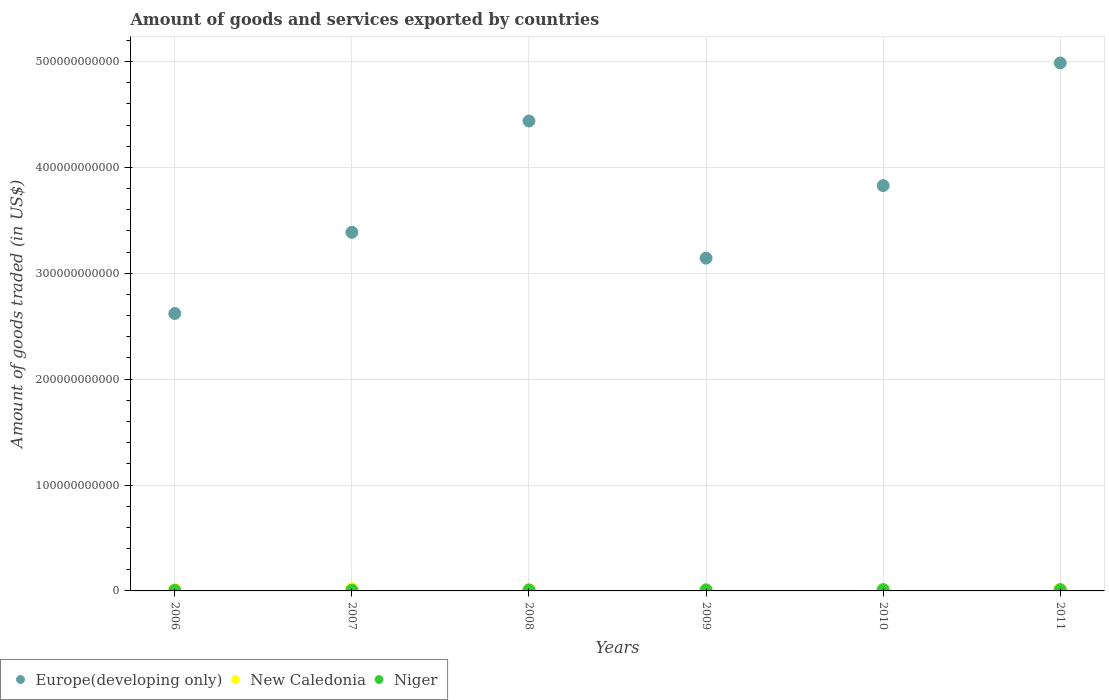How many different coloured dotlines are there?
Offer a very short reply. 3. What is the total amount of goods and services exported in Europe(developing only) in 2010?
Offer a very short reply. 3.83e+11. Across all years, what is the maximum total amount of goods and services exported in Niger?
Your response must be concise. 1.17e+09. Across all years, what is the minimum total amount of goods and services exported in New Caledonia?
Your answer should be very brief. 9.72e+08. What is the total total amount of goods and services exported in New Caledonia in the graph?
Ensure brevity in your answer.  8.77e+09. What is the difference between the total amount of goods and services exported in New Caledonia in 2006 and that in 2009?
Give a very brief answer. 3.71e+08. What is the difference between the total amount of goods and services exported in New Caledonia in 2006 and the total amount of goods and services exported in Niger in 2010?
Offer a terse response. 1.93e+08. What is the average total amount of goods and services exported in Europe(developing only) per year?
Offer a very short reply. 3.73e+11. In the year 2006, what is the difference between the total amount of goods and services exported in Europe(developing only) and total amount of goods and services exported in New Caledonia?
Your answer should be very brief. 2.61e+11. In how many years, is the total amount of goods and services exported in Europe(developing only) greater than 340000000000 US$?
Provide a succinct answer. 3. What is the ratio of the total amount of goods and services exported in New Caledonia in 2009 to that in 2010?
Make the answer very short. 0.69. Is the total amount of goods and services exported in Niger in 2008 less than that in 2010?
Your answer should be compact. Yes. Is the difference between the total amount of goods and services exported in Europe(developing only) in 2009 and 2011 greater than the difference between the total amount of goods and services exported in New Caledonia in 2009 and 2011?
Your answer should be very brief. No. What is the difference between the highest and the second highest total amount of goods and services exported in New Caledonia?
Offer a terse response. 4.38e+08. What is the difference between the highest and the lowest total amount of goods and services exported in Europe(developing only)?
Offer a very short reply. 2.37e+11. In how many years, is the total amount of goods and services exported in Europe(developing only) greater than the average total amount of goods and services exported in Europe(developing only) taken over all years?
Provide a short and direct response. 3. Is the total amount of goods and services exported in Niger strictly greater than the total amount of goods and services exported in New Caledonia over the years?
Provide a short and direct response. No. How many years are there in the graph?
Keep it short and to the point. 6. What is the difference between two consecutive major ticks on the Y-axis?
Offer a terse response. 1.00e+11. Does the graph contain grids?
Keep it short and to the point. Yes. What is the title of the graph?
Ensure brevity in your answer.  Amount of goods and services exported by countries. What is the label or title of the X-axis?
Your answer should be very brief. Years. What is the label or title of the Y-axis?
Make the answer very short. Amount of goods traded (in US$). What is the Amount of goods traded (in US$) of Europe(developing only) in 2006?
Your response must be concise. 2.62e+11. What is the Amount of goods traded (in US$) in New Caledonia in 2006?
Offer a terse response. 1.34e+09. What is the Amount of goods traded (in US$) of Niger in 2006?
Your answer should be compact. 5.08e+08. What is the Amount of goods traded (in US$) in Europe(developing only) in 2007?
Offer a very short reply. 3.39e+11. What is the Amount of goods traded (in US$) of New Caledonia in 2007?
Your answer should be compact. 2.12e+09. What is the Amount of goods traded (in US$) of Niger in 2007?
Ensure brevity in your answer.  6.63e+08. What is the Amount of goods traded (in US$) of Europe(developing only) in 2008?
Your response must be concise. 4.44e+11. What is the Amount of goods traded (in US$) in New Caledonia in 2008?
Make the answer very short. 1.23e+09. What is the Amount of goods traded (in US$) in Niger in 2008?
Make the answer very short. 9.12e+08. What is the Amount of goods traded (in US$) in Europe(developing only) in 2009?
Offer a terse response. 3.14e+11. What is the Amount of goods traded (in US$) of New Caledonia in 2009?
Keep it short and to the point. 9.72e+08. What is the Amount of goods traded (in US$) of Niger in 2009?
Give a very brief answer. 9.97e+08. What is the Amount of goods traded (in US$) of Europe(developing only) in 2010?
Keep it short and to the point. 3.83e+11. What is the Amount of goods traded (in US$) in New Caledonia in 2010?
Your answer should be compact. 1.42e+09. What is the Amount of goods traded (in US$) of Niger in 2010?
Your answer should be compact. 1.15e+09. What is the Amount of goods traded (in US$) of Europe(developing only) in 2011?
Provide a short and direct response. 4.99e+11. What is the Amount of goods traded (in US$) in New Caledonia in 2011?
Give a very brief answer. 1.68e+09. What is the Amount of goods traded (in US$) of Niger in 2011?
Ensure brevity in your answer.  1.17e+09. Across all years, what is the maximum Amount of goods traded (in US$) of Europe(developing only)?
Your answer should be very brief. 4.99e+11. Across all years, what is the maximum Amount of goods traded (in US$) of New Caledonia?
Provide a short and direct response. 2.12e+09. Across all years, what is the maximum Amount of goods traded (in US$) of Niger?
Your response must be concise. 1.17e+09. Across all years, what is the minimum Amount of goods traded (in US$) of Europe(developing only)?
Offer a terse response. 2.62e+11. Across all years, what is the minimum Amount of goods traded (in US$) of New Caledonia?
Keep it short and to the point. 9.72e+08. Across all years, what is the minimum Amount of goods traded (in US$) in Niger?
Provide a succinct answer. 5.08e+08. What is the total Amount of goods traded (in US$) of Europe(developing only) in the graph?
Keep it short and to the point. 2.24e+12. What is the total Amount of goods traded (in US$) of New Caledonia in the graph?
Your response must be concise. 8.77e+09. What is the total Amount of goods traded (in US$) of Niger in the graph?
Keep it short and to the point. 5.40e+09. What is the difference between the Amount of goods traded (in US$) in Europe(developing only) in 2006 and that in 2007?
Keep it short and to the point. -7.67e+1. What is the difference between the Amount of goods traded (in US$) in New Caledonia in 2006 and that in 2007?
Give a very brief answer. -7.79e+08. What is the difference between the Amount of goods traded (in US$) of Niger in 2006 and that in 2007?
Your answer should be compact. -1.55e+08. What is the difference between the Amount of goods traded (in US$) in Europe(developing only) in 2006 and that in 2008?
Ensure brevity in your answer.  -1.82e+11. What is the difference between the Amount of goods traded (in US$) of New Caledonia in 2006 and that in 2008?
Offer a terse response. 1.11e+08. What is the difference between the Amount of goods traded (in US$) in Niger in 2006 and that in 2008?
Offer a terse response. -4.04e+08. What is the difference between the Amount of goods traded (in US$) of Europe(developing only) in 2006 and that in 2009?
Your answer should be very brief. -5.23e+1. What is the difference between the Amount of goods traded (in US$) in New Caledonia in 2006 and that in 2009?
Provide a succinct answer. 3.71e+08. What is the difference between the Amount of goods traded (in US$) in Niger in 2006 and that in 2009?
Give a very brief answer. -4.89e+08. What is the difference between the Amount of goods traded (in US$) in Europe(developing only) in 2006 and that in 2010?
Keep it short and to the point. -1.21e+11. What is the difference between the Amount of goods traded (in US$) of New Caledonia in 2006 and that in 2010?
Provide a succinct answer. -7.29e+07. What is the difference between the Amount of goods traded (in US$) of Niger in 2006 and that in 2010?
Offer a terse response. -6.43e+08. What is the difference between the Amount of goods traded (in US$) of Europe(developing only) in 2006 and that in 2011?
Your response must be concise. -2.37e+11. What is the difference between the Amount of goods traded (in US$) in New Caledonia in 2006 and that in 2011?
Your answer should be compact. -3.40e+08. What is the difference between the Amount of goods traded (in US$) in Niger in 2006 and that in 2011?
Offer a very short reply. -6.65e+08. What is the difference between the Amount of goods traded (in US$) of Europe(developing only) in 2007 and that in 2008?
Make the answer very short. -1.05e+11. What is the difference between the Amount of goods traded (in US$) in New Caledonia in 2007 and that in 2008?
Your answer should be very brief. 8.90e+08. What is the difference between the Amount of goods traded (in US$) in Niger in 2007 and that in 2008?
Your answer should be compact. -2.50e+08. What is the difference between the Amount of goods traded (in US$) of Europe(developing only) in 2007 and that in 2009?
Offer a very short reply. 2.44e+1. What is the difference between the Amount of goods traded (in US$) in New Caledonia in 2007 and that in 2009?
Offer a terse response. 1.15e+09. What is the difference between the Amount of goods traded (in US$) in Niger in 2007 and that in 2009?
Your answer should be very brief. -3.34e+08. What is the difference between the Amount of goods traded (in US$) in Europe(developing only) in 2007 and that in 2010?
Provide a succinct answer. -4.41e+1. What is the difference between the Amount of goods traded (in US$) in New Caledonia in 2007 and that in 2010?
Provide a succinct answer. 7.06e+08. What is the difference between the Amount of goods traded (in US$) of Niger in 2007 and that in 2010?
Provide a succinct answer. -4.88e+08. What is the difference between the Amount of goods traded (in US$) of Europe(developing only) in 2007 and that in 2011?
Make the answer very short. -1.60e+11. What is the difference between the Amount of goods traded (in US$) of New Caledonia in 2007 and that in 2011?
Offer a very short reply. 4.38e+08. What is the difference between the Amount of goods traded (in US$) in Niger in 2007 and that in 2011?
Give a very brief answer. -5.10e+08. What is the difference between the Amount of goods traded (in US$) in Europe(developing only) in 2008 and that in 2009?
Provide a succinct answer. 1.29e+11. What is the difference between the Amount of goods traded (in US$) of New Caledonia in 2008 and that in 2009?
Keep it short and to the point. 2.60e+08. What is the difference between the Amount of goods traded (in US$) of Niger in 2008 and that in 2009?
Your answer should be very brief. -8.47e+07. What is the difference between the Amount of goods traded (in US$) in Europe(developing only) in 2008 and that in 2010?
Your answer should be compact. 6.10e+1. What is the difference between the Amount of goods traded (in US$) in New Caledonia in 2008 and that in 2010?
Offer a very short reply. -1.84e+08. What is the difference between the Amount of goods traded (in US$) in Niger in 2008 and that in 2010?
Keep it short and to the point. -2.39e+08. What is the difference between the Amount of goods traded (in US$) of Europe(developing only) in 2008 and that in 2011?
Offer a very short reply. -5.48e+1. What is the difference between the Amount of goods traded (in US$) of New Caledonia in 2008 and that in 2011?
Provide a succinct answer. -4.51e+08. What is the difference between the Amount of goods traded (in US$) of Niger in 2008 and that in 2011?
Offer a terse response. -2.61e+08. What is the difference between the Amount of goods traded (in US$) in Europe(developing only) in 2009 and that in 2010?
Your response must be concise. -6.85e+1. What is the difference between the Amount of goods traded (in US$) of New Caledonia in 2009 and that in 2010?
Offer a very short reply. -4.44e+08. What is the difference between the Amount of goods traded (in US$) in Niger in 2009 and that in 2010?
Offer a terse response. -1.54e+08. What is the difference between the Amount of goods traded (in US$) of Europe(developing only) in 2009 and that in 2011?
Ensure brevity in your answer.  -1.84e+11. What is the difference between the Amount of goods traded (in US$) in New Caledonia in 2009 and that in 2011?
Your response must be concise. -7.12e+08. What is the difference between the Amount of goods traded (in US$) in Niger in 2009 and that in 2011?
Offer a very short reply. -1.76e+08. What is the difference between the Amount of goods traded (in US$) of Europe(developing only) in 2010 and that in 2011?
Offer a very short reply. -1.16e+11. What is the difference between the Amount of goods traded (in US$) in New Caledonia in 2010 and that in 2011?
Your response must be concise. -2.67e+08. What is the difference between the Amount of goods traded (in US$) of Niger in 2010 and that in 2011?
Offer a terse response. -2.17e+07. What is the difference between the Amount of goods traded (in US$) of Europe(developing only) in 2006 and the Amount of goods traded (in US$) of New Caledonia in 2007?
Offer a very short reply. 2.60e+11. What is the difference between the Amount of goods traded (in US$) in Europe(developing only) in 2006 and the Amount of goods traded (in US$) in Niger in 2007?
Ensure brevity in your answer.  2.61e+11. What is the difference between the Amount of goods traded (in US$) in New Caledonia in 2006 and the Amount of goods traded (in US$) in Niger in 2007?
Your response must be concise. 6.81e+08. What is the difference between the Amount of goods traded (in US$) of Europe(developing only) in 2006 and the Amount of goods traded (in US$) of New Caledonia in 2008?
Make the answer very short. 2.61e+11. What is the difference between the Amount of goods traded (in US$) in Europe(developing only) in 2006 and the Amount of goods traded (in US$) in Niger in 2008?
Offer a very short reply. 2.61e+11. What is the difference between the Amount of goods traded (in US$) of New Caledonia in 2006 and the Amount of goods traded (in US$) of Niger in 2008?
Provide a succinct answer. 4.31e+08. What is the difference between the Amount of goods traded (in US$) of Europe(developing only) in 2006 and the Amount of goods traded (in US$) of New Caledonia in 2009?
Offer a very short reply. 2.61e+11. What is the difference between the Amount of goods traded (in US$) in Europe(developing only) in 2006 and the Amount of goods traded (in US$) in Niger in 2009?
Ensure brevity in your answer.  2.61e+11. What is the difference between the Amount of goods traded (in US$) in New Caledonia in 2006 and the Amount of goods traded (in US$) in Niger in 2009?
Provide a succinct answer. 3.47e+08. What is the difference between the Amount of goods traded (in US$) of Europe(developing only) in 2006 and the Amount of goods traded (in US$) of New Caledonia in 2010?
Make the answer very short. 2.61e+11. What is the difference between the Amount of goods traded (in US$) of Europe(developing only) in 2006 and the Amount of goods traded (in US$) of Niger in 2010?
Offer a very short reply. 2.61e+11. What is the difference between the Amount of goods traded (in US$) of New Caledonia in 2006 and the Amount of goods traded (in US$) of Niger in 2010?
Your answer should be very brief. 1.93e+08. What is the difference between the Amount of goods traded (in US$) of Europe(developing only) in 2006 and the Amount of goods traded (in US$) of New Caledonia in 2011?
Keep it short and to the point. 2.60e+11. What is the difference between the Amount of goods traded (in US$) in Europe(developing only) in 2006 and the Amount of goods traded (in US$) in Niger in 2011?
Give a very brief answer. 2.61e+11. What is the difference between the Amount of goods traded (in US$) in New Caledonia in 2006 and the Amount of goods traded (in US$) in Niger in 2011?
Provide a short and direct response. 1.71e+08. What is the difference between the Amount of goods traded (in US$) in Europe(developing only) in 2007 and the Amount of goods traded (in US$) in New Caledonia in 2008?
Provide a short and direct response. 3.37e+11. What is the difference between the Amount of goods traded (in US$) of Europe(developing only) in 2007 and the Amount of goods traded (in US$) of Niger in 2008?
Offer a very short reply. 3.38e+11. What is the difference between the Amount of goods traded (in US$) of New Caledonia in 2007 and the Amount of goods traded (in US$) of Niger in 2008?
Make the answer very short. 1.21e+09. What is the difference between the Amount of goods traded (in US$) of Europe(developing only) in 2007 and the Amount of goods traded (in US$) of New Caledonia in 2009?
Give a very brief answer. 3.38e+11. What is the difference between the Amount of goods traded (in US$) in Europe(developing only) in 2007 and the Amount of goods traded (in US$) in Niger in 2009?
Your answer should be compact. 3.38e+11. What is the difference between the Amount of goods traded (in US$) of New Caledonia in 2007 and the Amount of goods traded (in US$) of Niger in 2009?
Provide a short and direct response. 1.13e+09. What is the difference between the Amount of goods traded (in US$) in Europe(developing only) in 2007 and the Amount of goods traded (in US$) in New Caledonia in 2010?
Make the answer very short. 3.37e+11. What is the difference between the Amount of goods traded (in US$) in Europe(developing only) in 2007 and the Amount of goods traded (in US$) in Niger in 2010?
Make the answer very short. 3.38e+11. What is the difference between the Amount of goods traded (in US$) of New Caledonia in 2007 and the Amount of goods traded (in US$) of Niger in 2010?
Provide a succinct answer. 9.71e+08. What is the difference between the Amount of goods traded (in US$) in Europe(developing only) in 2007 and the Amount of goods traded (in US$) in New Caledonia in 2011?
Provide a succinct answer. 3.37e+11. What is the difference between the Amount of goods traded (in US$) in Europe(developing only) in 2007 and the Amount of goods traded (in US$) in Niger in 2011?
Provide a succinct answer. 3.38e+11. What is the difference between the Amount of goods traded (in US$) in New Caledonia in 2007 and the Amount of goods traded (in US$) in Niger in 2011?
Provide a short and direct response. 9.50e+08. What is the difference between the Amount of goods traded (in US$) in Europe(developing only) in 2008 and the Amount of goods traded (in US$) in New Caledonia in 2009?
Make the answer very short. 4.43e+11. What is the difference between the Amount of goods traded (in US$) in Europe(developing only) in 2008 and the Amount of goods traded (in US$) in Niger in 2009?
Ensure brevity in your answer.  4.43e+11. What is the difference between the Amount of goods traded (in US$) in New Caledonia in 2008 and the Amount of goods traded (in US$) in Niger in 2009?
Ensure brevity in your answer.  2.36e+08. What is the difference between the Amount of goods traded (in US$) in Europe(developing only) in 2008 and the Amount of goods traded (in US$) in New Caledonia in 2010?
Your response must be concise. 4.42e+11. What is the difference between the Amount of goods traded (in US$) of Europe(developing only) in 2008 and the Amount of goods traded (in US$) of Niger in 2010?
Your answer should be very brief. 4.43e+11. What is the difference between the Amount of goods traded (in US$) in New Caledonia in 2008 and the Amount of goods traded (in US$) in Niger in 2010?
Provide a short and direct response. 8.17e+07. What is the difference between the Amount of goods traded (in US$) in Europe(developing only) in 2008 and the Amount of goods traded (in US$) in New Caledonia in 2011?
Your response must be concise. 4.42e+11. What is the difference between the Amount of goods traded (in US$) of Europe(developing only) in 2008 and the Amount of goods traded (in US$) of Niger in 2011?
Your answer should be very brief. 4.43e+11. What is the difference between the Amount of goods traded (in US$) in New Caledonia in 2008 and the Amount of goods traded (in US$) in Niger in 2011?
Your answer should be compact. 6.00e+07. What is the difference between the Amount of goods traded (in US$) of Europe(developing only) in 2009 and the Amount of goods traded (in US$) of New Caledonia in 2010?
Ensure brevity in your answer.  3.13e+11. What is the difference between the Amount of goods traded (in US$) in Europe(developing only) in 2009 and the Amount of goods traded (in US$) in Niger in 2010?
Provide a succinct answer. 3.13e+11. What is the difference between the Amount of goods traded (in US$) of New Caledonia in 2009 and the Amount of goods traded (in US$) of Niger in 2010?
Keep it short and to the point. -1.79e+08. What is the difference between the Amount of goods traded (in US$) of Europe(developing only) in 2009 and the Amount of goods traded (in US$) of New Caledonia in 2011?
Provide a short and direct response. 3.13e+11. What is the difference between the Amount of goods traded (in US$) in Europe(developing only) in 2009 and the Amount of goods traded (in US$) in Niger in 2011?
Provide a short and direct response. 3.13e+11. What is the difference between the Amount of goods traded (in US$) in New Caledonia in 2009 and the Amount of goods traded (in US$) in Niger in 2011?
Your response must be concise. -2.00e+08. What is the difference between the Amount of goods traded (in US$) of Europe(developing only) in 2010 and the Amount of goods traded (in US$) of New Caledonia in 2011?
Give a very brief answer. 3.81e+11. What is the difference between the Amount of goods traded (in US$) in Europe(developing only) in 2010 and the Amount of goods traded (in US$) in Niger in 2011?
Give a very brief answer. 3.82e+11. What is the difference between the Amount of goods traded (in US$) in New Caledonia in 2010 and the Amount of goods traded (in US$) in Niger in 2011?
Your answer should be very brief. 2.44e+08. What is the average Amount of goods traded (in US$) in Europe(developing only) per year?
Give a very brief answer. 3.73e+11. What is the average Amount of goods traded (in US$) of New Caledonia per year?
Offer a terse response. 1.46e+09. What is the average Amount of goods traded (in US$) of Niger per year?
Make the answer very short. 9.01e+08. In the year 2006, what is the difference between the Amount of goods traded (in US$) in Europe(developing only) and Amount of goods traded (in US$) in New Caledonia?
Ensure brevity in your answer.  2.61e+11. In the year 2006, what is the difference between the Amount of goods traded (in US$) in Europe(developing only) and Amount of goods traded (in US$) in Niger?
Offer a terse response. 2.62e+11. In the year 2006, what is the difference between the Amount of goods traded (in US$) of New Caledonia and Amount of goods traded (in US$) of Niger?
Provide a short and direct response. 8.36e+08. In the year 2007, what is the difference between the Amount of goods traded (in US$) of Europe(developing only) and Amount of goods traded (in US$) of New Caledonia?
Your response must be concise. 3.37e+11. In the year 2007, what is the difference between the Amount of goods traded (in US$) of Europe(developing only) and Amount of goods traded (in US$) of Niger?
Give a very brief answer. 3.38e+11. In the year 2007, what is the difference between the Amount of goods traded (in US$) of New Caledonia and Amount of goods traded (in US$) of Niger?
Your response must be concise. 1.46e+09. In the year 2008, what is the difference between the Amount of goods traded (in US$) of Europe(developing only) and Amount of goods traded (in US$) of New Caledonia?
Keep it short and to the point. 4.43e+11. In the year 2008, what is the difference between the Amount of goods traded (in US$) in Europe(developing only) and Amount of goods traded (in US$) in Niger?
Your answer should be compact. 4.43e+11. In the year 2008, what is the difference between the Amount of goods traded (in US$) of New Caledonia and Amount of goods traded (in US$) of Niger?
Ensure brevity in your answer.  3.21e+08. In the year 2009, what is the difference between the Amount of goods traded (in US$) of Europe(developing only) and Amount of goods traded (in US$) of New Caledonia?
Provide a succinct answer. 3.13e+11. In the year 2009, what is the difference between the Amount of goods traded (in US$) in Europe(developing only) and Amount of goods traded (in US$) in Niger?
Make the answer very short. 3.13e+11. In the year 2009, what is the difference between the Amount of goods traded (in US$) of New Caledonia and Amount of goods traded (in US$) of Niger?
Your response must be concise. -2.46e+07. In the year 2010, what is the difference between the Amount of goods traded (in US$) of Europe(developing only) and Amount of goods traded (in US$) of New Caledonia?
Offer a very short reply. 3.81e+11. In the year 2010, what is the difference between the Amount of goods traded (in US$) in Europe(developing only) and Amount of goods traded (in US$) in Niger?
Offer a terse response. 3.82e+11. In the year 2010, what is the difference between the Amount of goods traded (in US$) of New Caledonia and Amount of goods traded (in US$) of Niger?
Your response must be concise. 2.65e+08. In the year 2011, what is the difference between the Amount of goods traded (in US$) in Europe(developing only) and Amount of goods traded (in US$) in New Caledonia?
Give a very brief answer. 4.97e+11. In the year 2011, what is the difference between the Amount of goods traded (in US$) of Europe(developing only) and Amount of goods traded (in US$) of Niger?
Keep it short and to the point. 4.97e+11. In the year 2011, what is the difference between the Amount of goods traded (in US$) in New Caledonia and Amount of goods traded (in US$) in Niger?
Your answer should be very brief. 5.11e+08. What is the ratio of the Amount of goods traded (in US$) of Europe(developing only) in 2006 to that in 2007?
Your answer should be very brief. 0.77. What is the ratio of the Amount of goods traded (in US$) of New Caledonia in 2006 to that in 2007?
Make the answer very short. 0.63. What is the ratio of the Amount of goods traded (in US$) of Niger in 2006 to that in 2007?
Your answer should be compact. 0.77. What is the ratio of the Amount of goods traded (in US$) in Europe(developing only) in 2006 to that in 2008?
Offer a very short reply. 0.59. What is the ratio of the Amount of goods traded (in US$) in New Caledonia in 2006 to that in 2008?
Make the answer very short. 1.09. What is the ratio of the Amount of goods traded (in US$) in Niger in 2006 to that in 2008?
Ensure brevity in your answer.  0.56. What is the ratio of the Amount of goods traded (in US$) in Europe(developing only) in 2006 to that in 2009?
Your answer should be compact. 0.83. What is the ratio of the Amount of goods traded (in US$) in New Caledonia in 2006 to that in 2009?
Give a very brief answer. 1.38. What is the ratio of the Amount of goods traded (in US$) of Niger in 2006 to that in 2009?
Ensure brevity in your answer.  0.51. What is the ratio of the Amount of goods traded (in US$) in Europe(developing only) in 2006 to that in 2010?
Make the answer very short. 0.68. What is the ratio of the Amount of goods traded (in US$) in New Caledonia in 2006 to that in 2010?
Offer a very short reply. 0.95. What is the ratio of the Amount of goods traded (in US$) of Niger in 2006 to that in 2010?
Provide a succinct answer. 0.44. What is the ratio of the Amount of goods traded (in US$) in Europe(developing only) in 2006 to that in 2011?
Provide a succinct answer. 0.53. What is the ratio of the Amount of goods traded (in US$) in New Caledonia in 2006 to that in 2011?
Offer a very short reply. 0.8. What is the ratio of the Amount of goods traded (in US$) in Niger in 2006 to that in 2011?
Your response must be concise. 0.43. What is the ratio of the Amount of goods traded (in US$) of Europe(developing only) in 2007 to that in 2008?
Give a very brief answer. 0.76. What is the ratio of the Amount of goods traded (in US$) in New Caledonia in 2007 to that in 2008?
Give a very brief answer. 1.72. What is the ratio of the Amount of goods traded (in US$) in Niger in 2007 to that in 2008?
Your answer should be compact. 0.73. What is the ratio of the Amount of goods traded (in US$) in Europe(developing only) in 2007 to that in 2009?
Offer a terse response. 1.08. What is the ratio of the Amount of goods traded (in US$) of New Caledonia in 2007 to that in 2009?
Your answer should be compact. 2.18. What is the ratio of the Amount of goods traded (in US$) of Niger in 2007 to that in 2009?
Offer a very short reply. 0.66. What is the ratio of the Amount of goods traded (in US$) in Europe(developing only) in 2007 to that in 2010?
Give a very brief answer. 0.88. What is the ratio of the Amount of goods traded (in US$) in New Caledonia in 2007 to that in 2010?
Provide a short and direct response. 1.5. What is the ratio of the Amount of goods traded (in US$) of Niger in 2007 to that in 2010?
Offer a terse response. 0.58. What is the ratio of the Amount of goods traded (in US$) of Europe(developing only) in 2007 to that in 2011?
Your answer should be very brief. 0.68. What is the ratio of the Amount of goods traded (in US$) of New Caledonia in 2007 to that in 2011?
Offer a very short reply. 1.26. What is the ratio of the Amount of goods traded (in US$) of Niger in 2007 to that in 2011?
Provide a short and direct response. 0.56. What is the ratio of the Amount of goods traded (in US$) in Europe(developing only) in 2008 to that in 2009?
Provide a short and direct response. 1.41. What is the ratio of the Amount of goods traded (in US$) in New Caledonia in 2008 to that in 2009?
Make the answer very short. 1.27. What is the ratio of the Amount of goods traded (in US$) in Niger in 2008 to that in 2009?
Provide a short and direct response. 0.92. What is the ratio of the Amount of goods traded (in US$) of Europe(developing only) in 2008 to that in 2010?
Keep it short and to the point. 1.16. What is the ratio of the Amount of goods traded (in US$) in New Caledonia in 2008 to that in 2010?
Your response must be concise. 0.87. What is the ratio of the Amount of goods traded (in US$) of Niger in 2008 to that in 2010?
Provide a succinct answer. 0.79. What is the ratio of the Amount of goods traded (in US$) of Europe(developing only) in 2008 to that in 2011?
Provide a short and direct response. 0.89. What is the ratio of the Amount of goods traded (in US$) in New Caledonia in 2008 to that in 2011?
Offer a terse response. 0.73. What is the ratio of the Amount of goods traded (in US$) in Europe(developing only) in 2009 to that in 2010?
Your answer should be compact. 0.82. What is the ratio of the Amount of goods traded (in US$) in New Caledonia in 2009 to that in 2010?
Your response must be concise. 0.69. What is the ratio of the Amount of goods traded (in US$) in Niger in 2009 to that in 2010?
Offer a very short reply. 0.87. What is the ratio of the Amount of goods traded (in US$) in Europe(developing only) in 2009 to that in 2011?
Offer a terse response. 0.63. What is the ratio of the Amount of goods traded (in US$) of New Caledonia in 2009 to that in 2011?
Keep it short and to the point. 0.58. What is the ratio of the Amount of goods traded (in US$) of Europe(developing only) in 2010 to that in 2011?
Ensure brevity in your answer.  0.77. What is the ratio of the Amount of goods traded (in US$) of New Caledonia in 2010 to that in 2011?
Offer a terse response. 0.84. What is the ratio of the Amount of goods traded (in US$) of Niger in 2010 to that in 2011?
Offer a terse response. 0.98. What is the difference between the highest and the second highest Amount of goods traded (in US$) in Europe(developing only)?
Offer a very short reply. 5.48e+1. What is the difference between the highest and the second highest Amount of goods traded (in US$) of New Caledonia?
Your response must be concise. 4.38e+08. What is the difference between the highest and the second highest Amount of goods traded (in US$) in Niger?
Make the answer very short. 2.17e+07. What is the difference between the highest and the lowest Amount of goods traded (in US$) in Europe(developing only)?
Your response must be concise. 2.37e+11. What is the difference between the highest and the lowest Amount of goods traded (in US$) of New Caledonia?
Ensure brevity in your answer.  1.15e+09. What is the difference between the highest and the lowest Amount of goods traded (in US$) of Niger?
Offer a very short reply. 6.65e+08. 